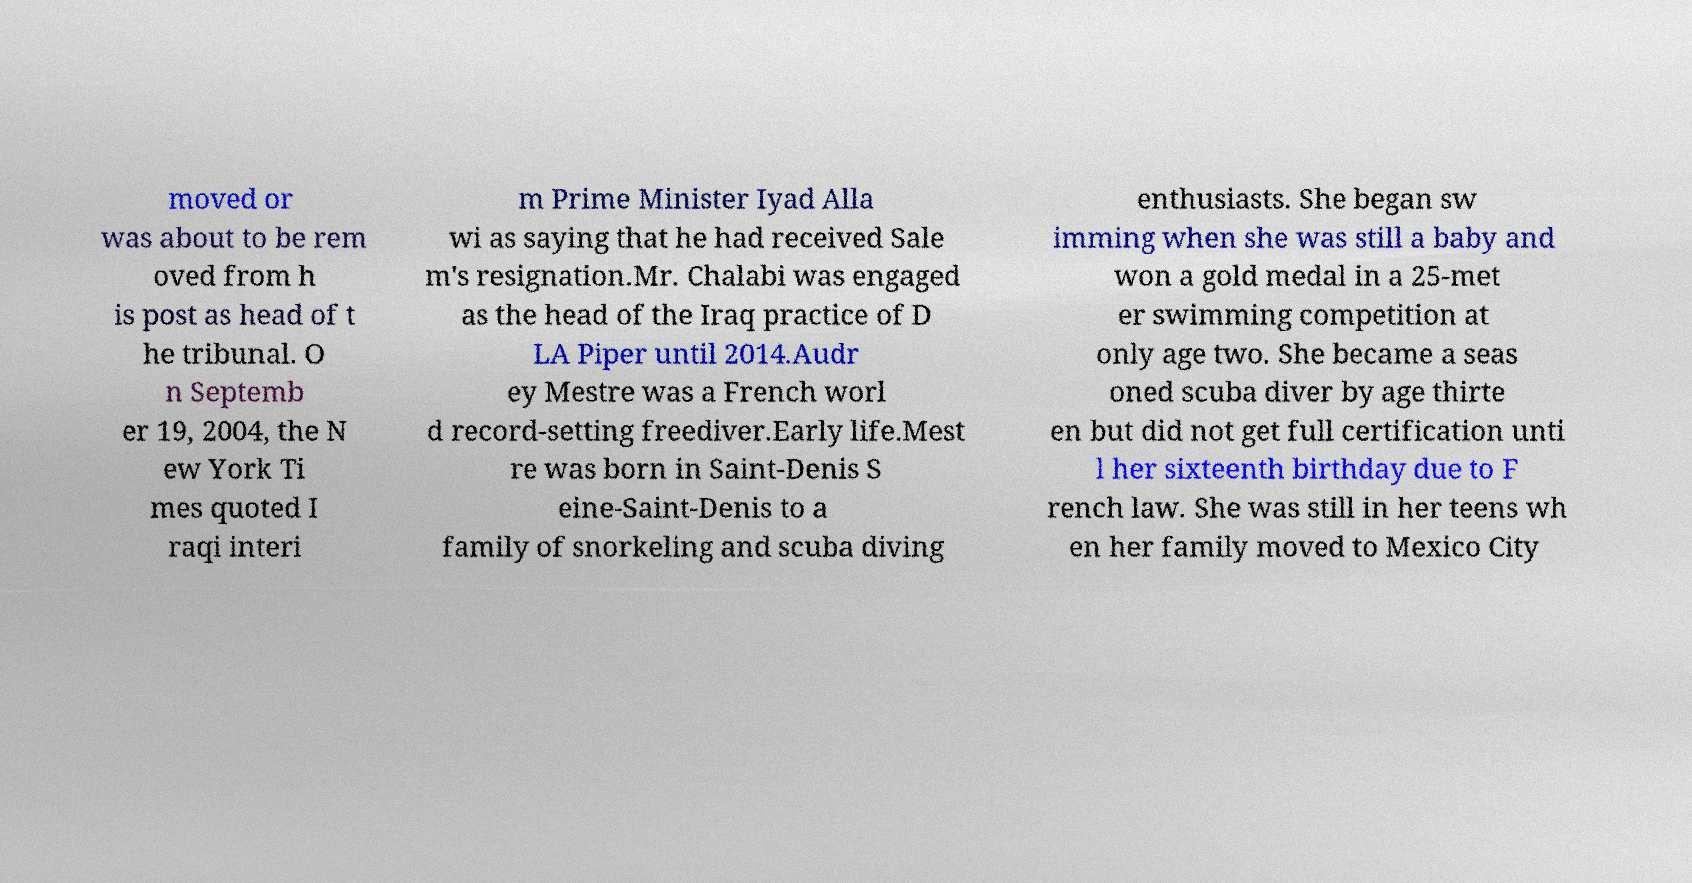There's text embedded in this image that I need extracted. Can you transcribe it verbatim? moved or was about to be rem oved from h is post as head of t he tribunal. O n Septemb er 19, 2004, the N ew York Ti mes quoted I raqi interi m Prime Minister Iyad Alla wi as saying that he had received Sale m's resignation.Mr. Chalabi was engaged as the head of the Iraq practice of D LA Piper until 2014.Audr ey Mestre was a French worl d record-setting freediver.Early life.Mest re was born in Saint-Denis S eine-Saint-Denis to a family of snorkeling and scuba diving enthusiasts. She began sw imming when she was still a baby and won a gold medal in a 25-met er swimming competition at only age two. She became a seas oned scuba diver by age thirte en but did not get full certification unti l her sixteenth birthday due to F rench law. She was still in her teens wh en her family moved to Mexico City 